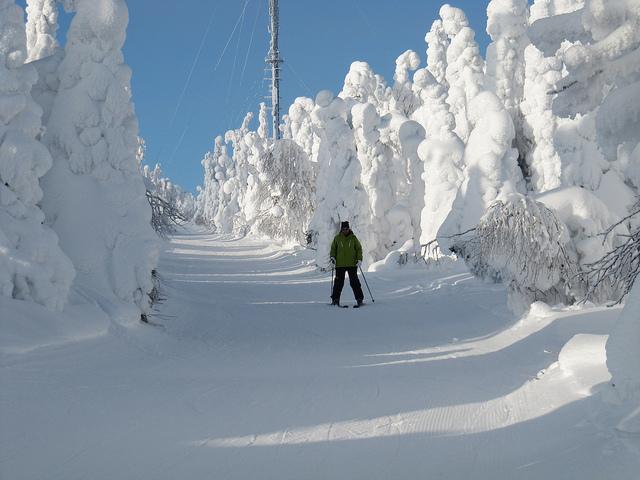Is there a stand in the pic?
Short answer required. No. Is this man wearing skis?
Write a very short answer. Yes. What is underneath the tall columns of snow on either side of the trail?
Concise answer only. Trees. How many people are skiing?
Short answer required. 1. 